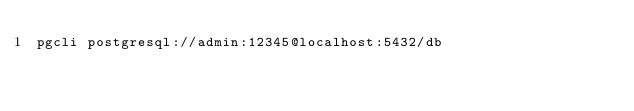Convert code to text. <code><loc_0><loc_0><loc_500><loc_500><_Bash_>pgcli postgresql://admin:12345@localhost:5432/db
</code> 